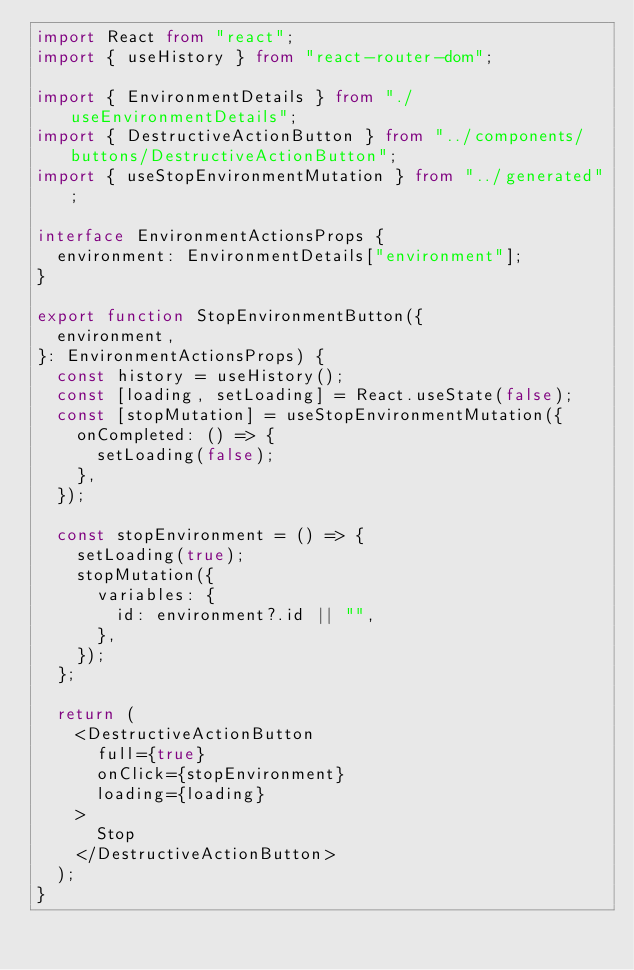<code> <loc_0><loc_0><loc_500><loc_500><_TypeScript_>import React from "react";
import { useHistory } from "react-router-dom";

import { EnvironmentDetails } from "./useEnvironmentDetails";
import { DestructiveActionButton } from "../components/buttons/DestructiveActionButton";
import { useStopEnvironmentMutation } from "../generated";

interface EnvironmentActionsProps {
  environment: EnvironmentDetails["environment"];
}

export function StopEnvironmentButton({
  environment,
}: EnvironmentActionsProps) {
  const history = useHistory();
  const [loading, setLoading] = React.useState(false);
  const [stopMutation] = useStopEnvironmentMutation({
    onCompleted: () => {
      setLoading(false);
    },
  });

  const stopEnvironment = () => {
    setLoading(true);
    stopMutation({
      variables: {
        id: environment?.id || "",
      },
    });
  };

  return (
    <DestructiveActionButton
      full={true}
      onClick={stopEnvironment}
      loading={loading}
    >
      Stop
    </DestructiveActionButton>
  );
}
</code> 